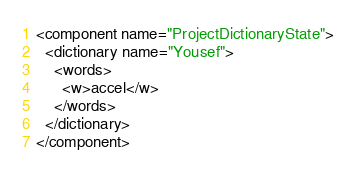<code> <loc_0><loc_0><loc_500><loc_500><_XML_><component name="ProjectDictionaryState">
  <dictionary name="Yousef">
    <words>
      <w>accel</w>
    </words>
  </dictionary>
</component></code> 